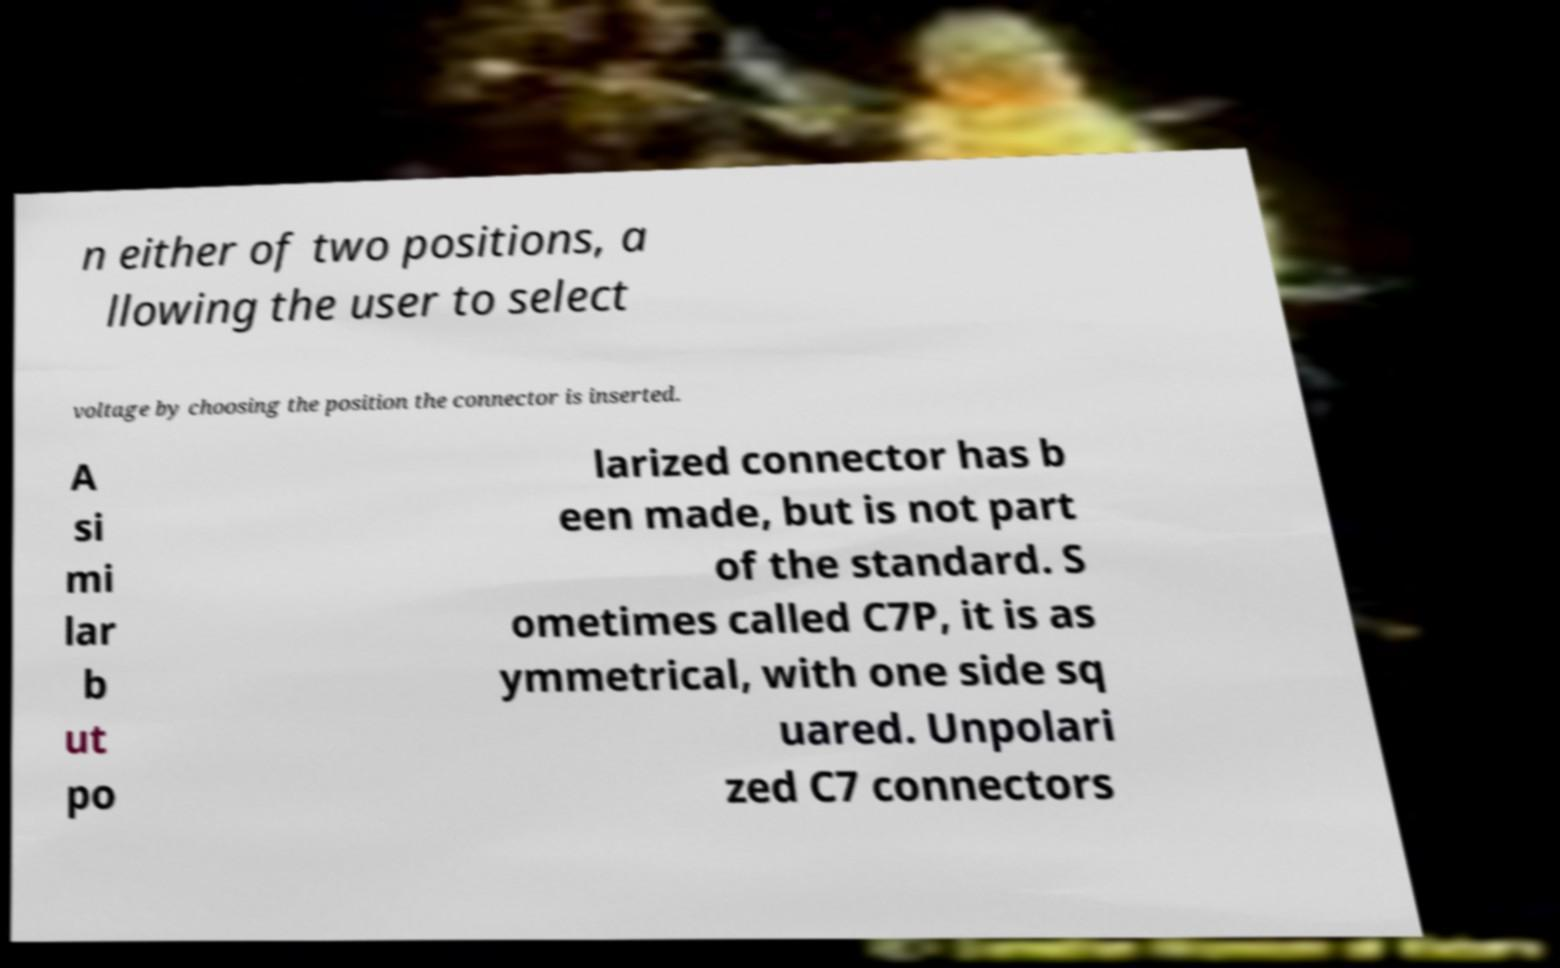Could you assist in decoding the text presented in this image and type it out clearly? n either of two positions, a llowing the user to select voltage by choosing the position the connector is inserted. A si mi lar b ut po larized connector has b een made, but is not part of the standard. S ometimes called C7P, it is as ymmetrical, with one side sq uared. Unpolari zed C7 connectors 